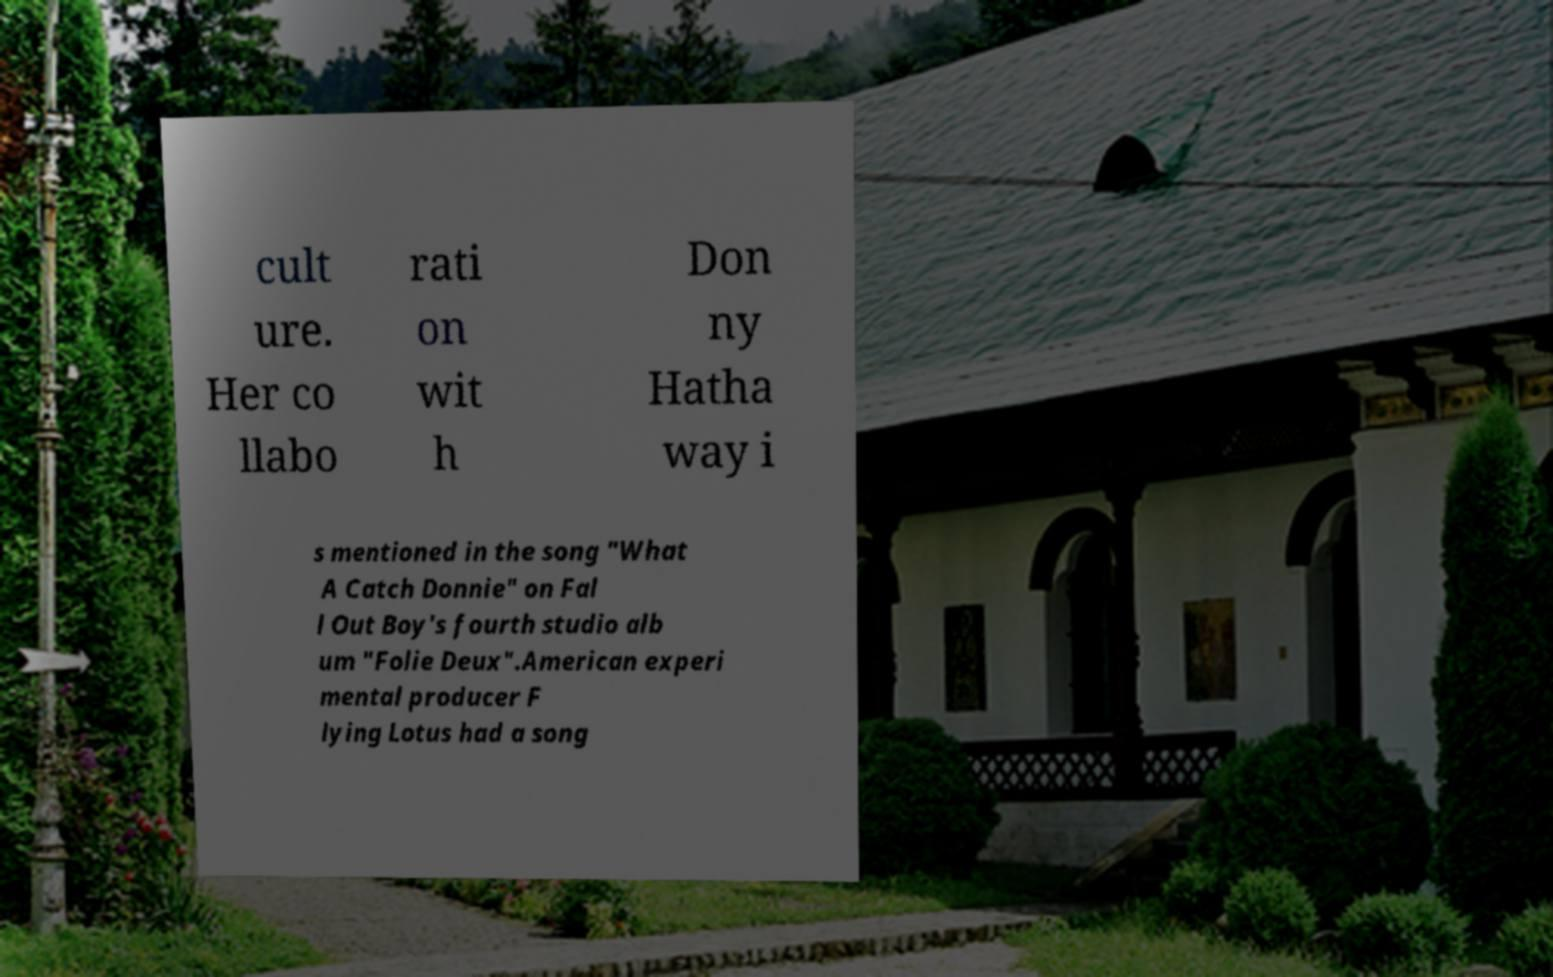Please identify and transcribe the text found in this image. cult ure. Her co llabo rati on wit h Don ny Hatha way i s mentioned in the song "What A Catch Donnie" on Fal l Out Boy's fourth studio alb um "Folie Deux".American experi mental producer F lying Lotus had a song 